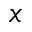<formula> <loc_0><loc_0><loc_500><loc_500>x</formula> 